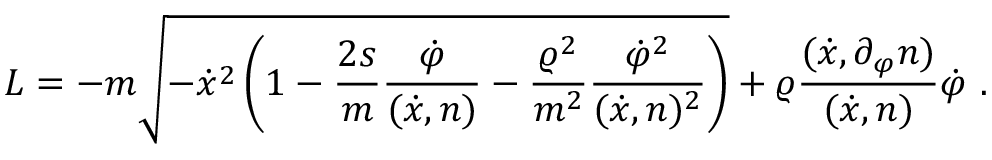Convert formula to latex. <formula><loc_0><loc_0><loc_500><loc_500>L = - m \sqrt { - \dot { x } ^ { 2 } \left ( 1 - \frac { 2 s } { m } \frac { \dot { \varphi } } { ( \dot { x } , n ) } - \frac { \varrho ^ { 2 } } { m ^ { 2 } } \frac { \dot { \varphi } ^ { 2 } } { ( \dot { x } , n ) ^ { 2 } } \right ) } + \varrho \frac { ( \dot { x } , \partial _ { \varphi } n ) } { ( \dot { x } , n ) } \dot { \varphi } \ .</formula> 